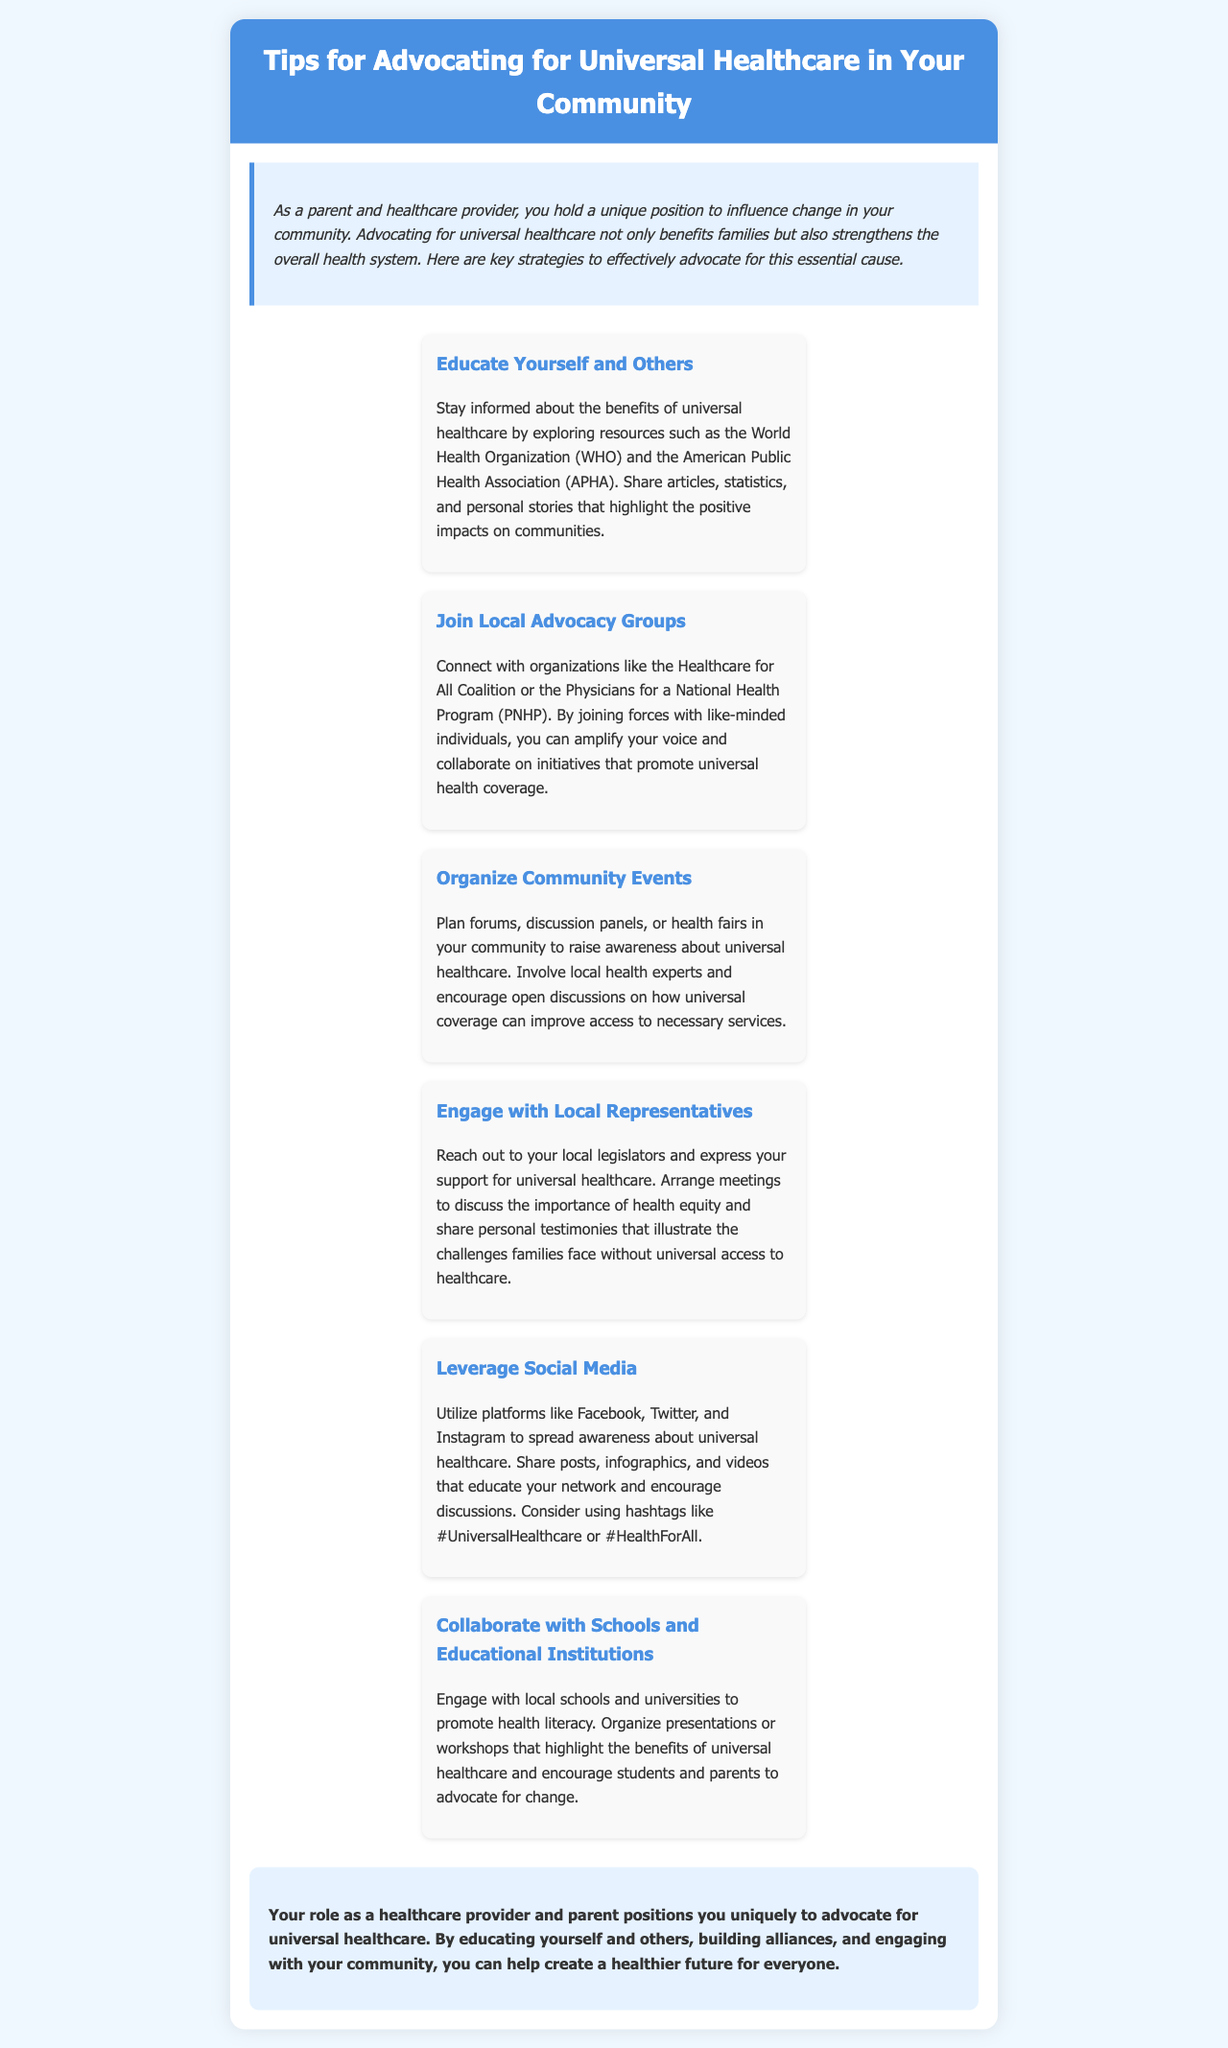What is the title of the brochure? The title is prominently displayed at the top of the document, stating the main topic.
Answer: Tips for Advocating for Universal Healthcare in Your Community How many main tips are provided in the brochure? The document lists a total of six tips for advocacy, each presented in a separate section.
Answer: 6 Which organization is suggested for joining advocacy groups? The brochure mentions specific organizations that can provide support and amplify advocacy efforts.
Answer: Healthcare for All Coalition What color is used for the header background? The background color of the header section is specified in the style rules within the document.
Answer: Blue What is the main purpose of the brochure? The introductory section outlines the overall intention behind the brochure's creation.
Answer: Advocate for universal healthcare Name one method suggested for spreading awareness on social media. The document provides specific social media strategies to raise awareness about universal healthcare.
Answer: Share posts What personal role is highlighted in the introduction? The introduction describes the unique position of a specific group that can influence community health policy.
Answer: Healthcare provider What type of events does the brochure suggest organizing? Recommendations include community-oriented activities aimed at increasing awareness and understanding of healthcare issues.
Answer: Forums or health fairs What is the concluding message of the brochure? The conclusion emphasizes the impact of education and community engagement in advocating for health reforms.
Answer: Create a healthier future for everyone 